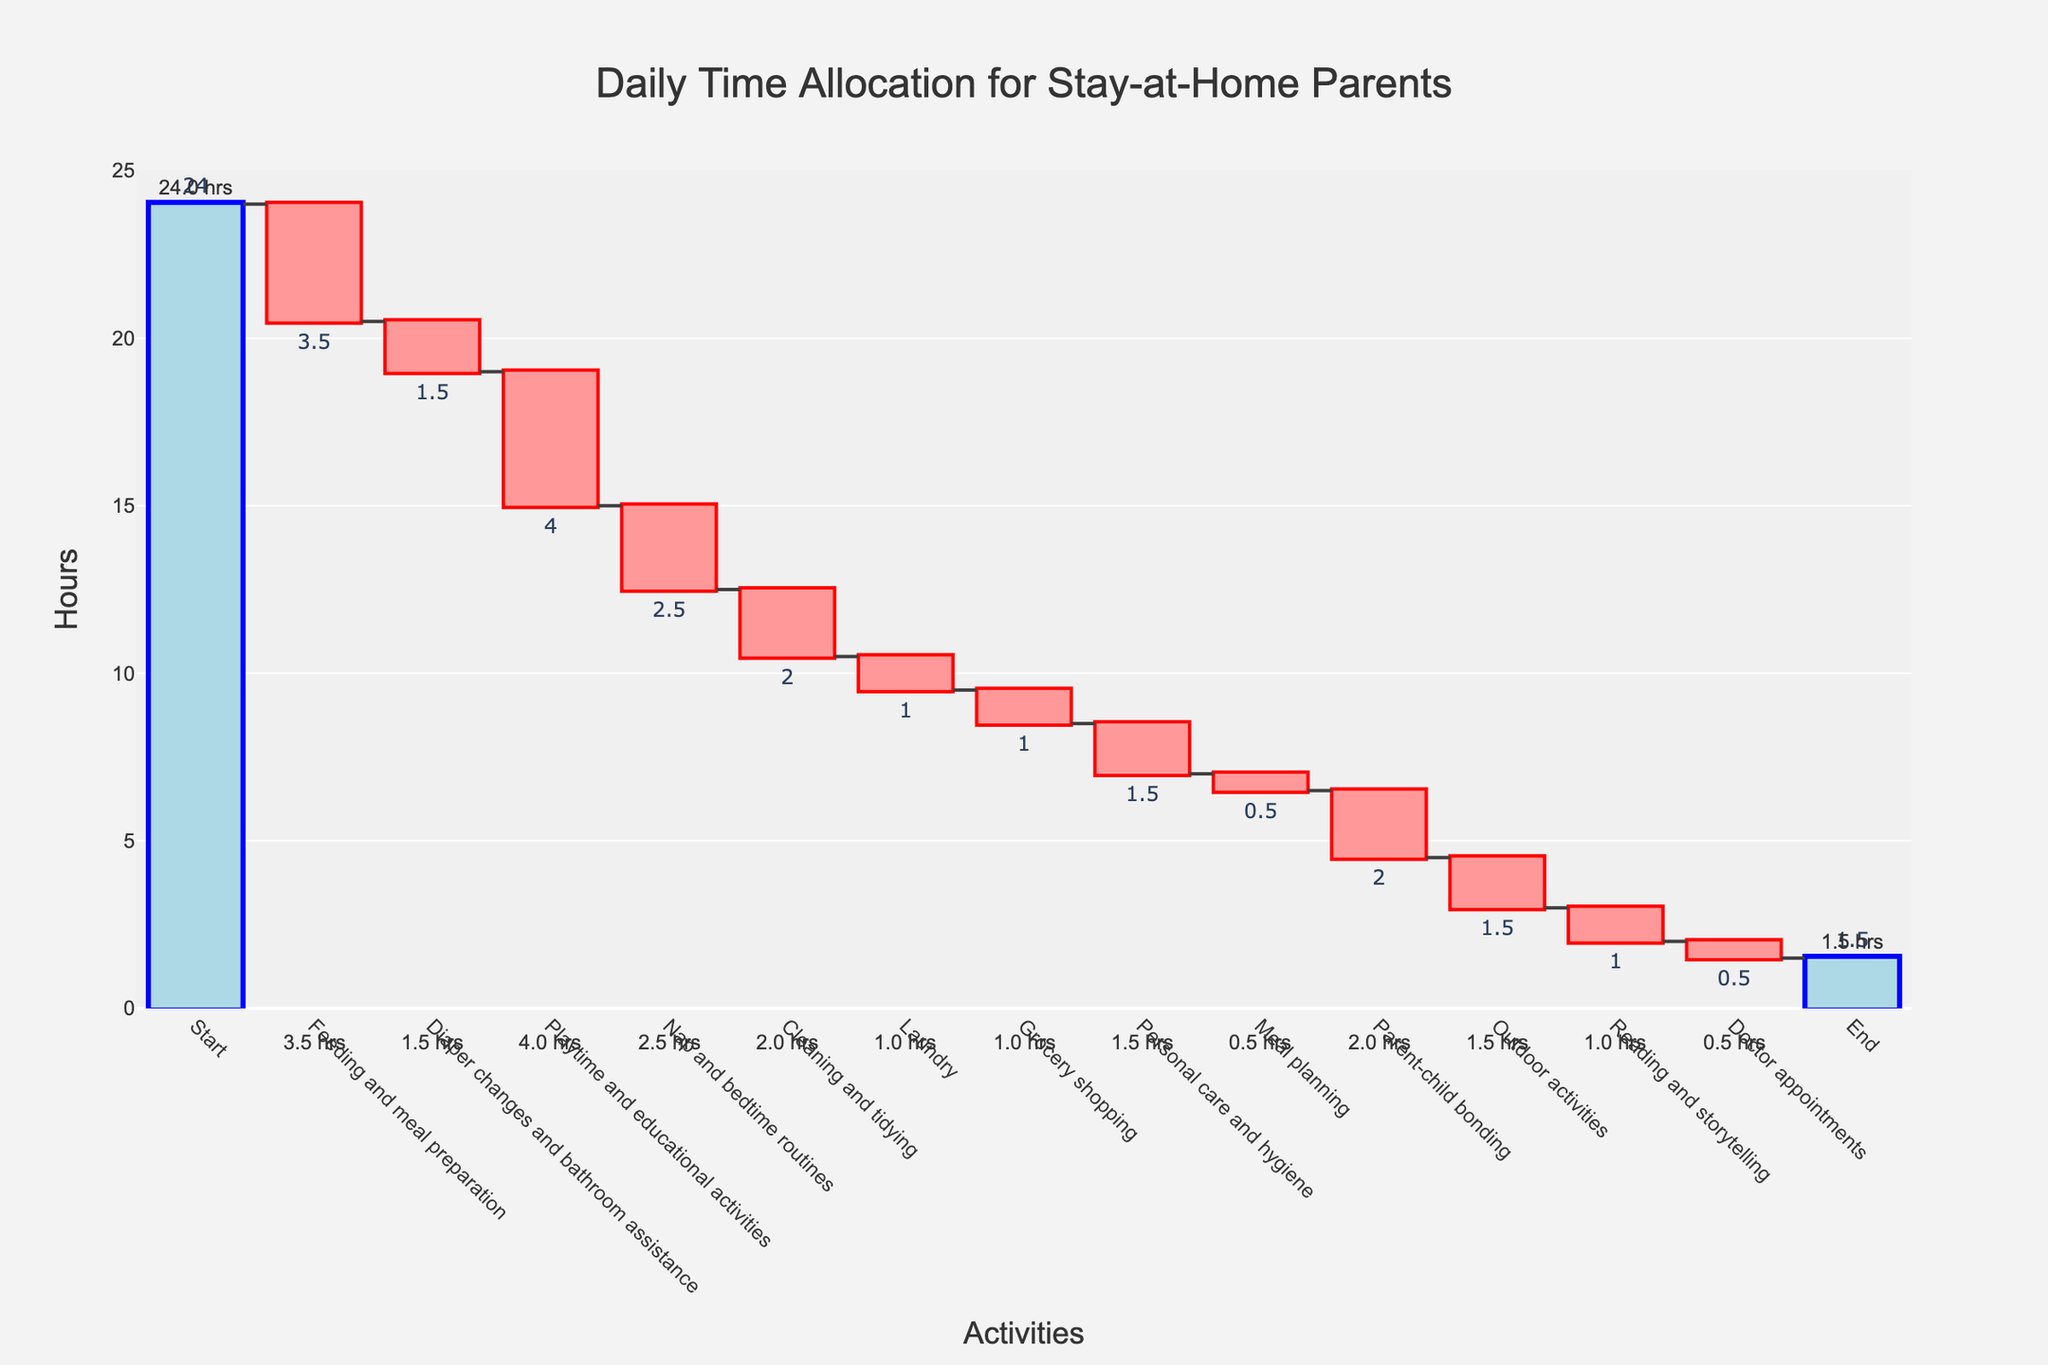How many hours are allocated to grocery shopping? The chart shows the activity "Grocery shopping" with a negative bar labeled "-1". This indicates that 1 hour is allocated to grocery shopping.
Answer: 1 Which activity takes the most hours? The chart shows various negative bars and their labels. The activity "Feeding and meal preparation" has the largest decrease with a label of "-3.5", indicating it takes the most hours.
Answer: Feeding and meal preparation How much time is dedicated to playtime and educational activities compared to outdoor activities? The chart shows a negative bar for "Playtime and educational activities" with a label of "-4". It also shows a negative bar for "Outdoor activities" with a label of "-1.5". Subtracting these values gives 4 - 1.5 = 2.5 hours more for playtime and educational activities.
Answer: 2.5 hours more What is the total decrease in hours for cleaning and tidying and laundry combined? The chart shows a negative bar for "Cleaning and tidying" with a label of "-2" and for "Laundry" with a label of "-1". Adding these values gives 2 + 1 = 3 hours of total decrease.
Answer: 3 hours What is the overall time remaining after all activities? The chart has a total bar at the end labeled "1.5" showing the overall remaining time after all activities have been accounted for.
Answer: 1.5 hours Which activity contributes the least amount of time? The chart shows various negative bars and their labels. The activity "Meal planning" has a label of "-0.5", indicating it contributes the least amount of time.
Answer: Meal planning How does the time spent on personal care and hygiene compare to doctor appointments? The chart shows a negative bar for "Personal care and hygiene" with a label of "-1.5" and for "Doctor appointments" with a label of "-0.5". Subtracting these values gives 1.5 - 0.5 = 1 hour more for personal care and hygiene.
Answer: 1 hour more How many total activities are shown on the chart? The chart lists each activity along the x-axis. Counting each activity from start to end results in 15 activities.
Answer: 15 activities 